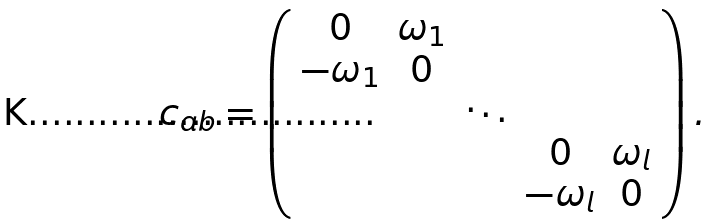Convert formula to latex. <formula><loc_0><loc_0><loc_500><loc_500>c _ { a b } = \left ( \begin{array} { c c c c c } 0 & \omega _ { 1 } & & & \\ - \omega _ { 1 } & 0 & & & \\ & & \ddots & & \\ & & & 0 & \omega _ { l } \\ & & & - \omega _ { l } & 0 \\ \end{array} \right ) .</formula> 